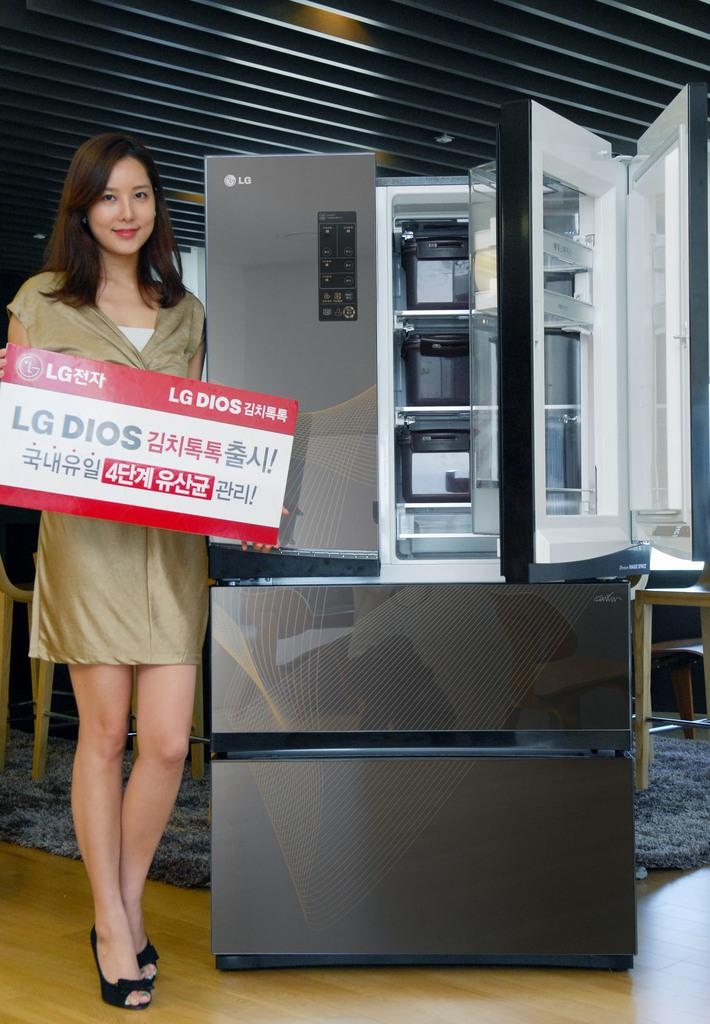<image>
Render a clear and concise summary of the photo. Lady in front of an LG refrigerator holding a sign written in Chinese. 